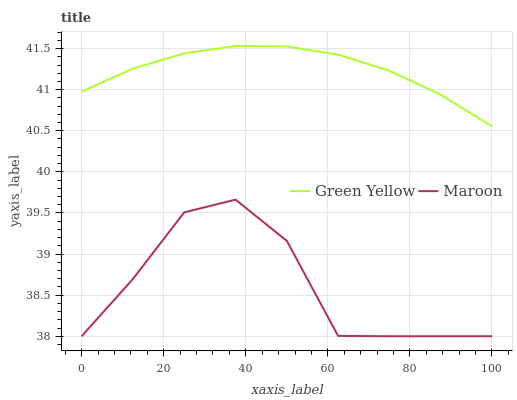Does Maroon have the minimum area under the curve?
Answer yes or no. Yes. Does Green Yellow have the maximum area under the curve?
Answer yes or no. Yes. Does Maroon have the maximum area under the curve?
Answer yes or no. No. Is Green Yellow the smoothest?
Answer yes or no. Yes. Is Maroon the roughest?
Answer yes or no. Yes. Is Maroon the smoothest?
Answer yes or no. No. Does Maroon have the lowest value?
Answer yes or no. Yes. Does Green Yellow have the highest value?
Answer yes or no. Yes. Does Maroon have the highest value?
Answer yes or no. No. Is Maroon less than Green Yellow?
Answer yes or no. Yes. Is Green Yellow greater than Maroon?
Answer yes or no. Yes. Does Maroon intersect Green Yellow?
Answer yes or no. No. 